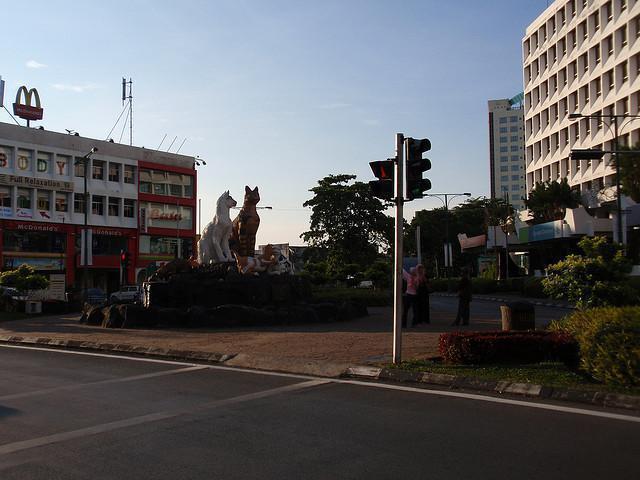What type of burger could be eaten here?
From the following set of four choices, select the accurate answer to respond to the question.
Options: None, big mac, kfc, whopper. Big mac. 